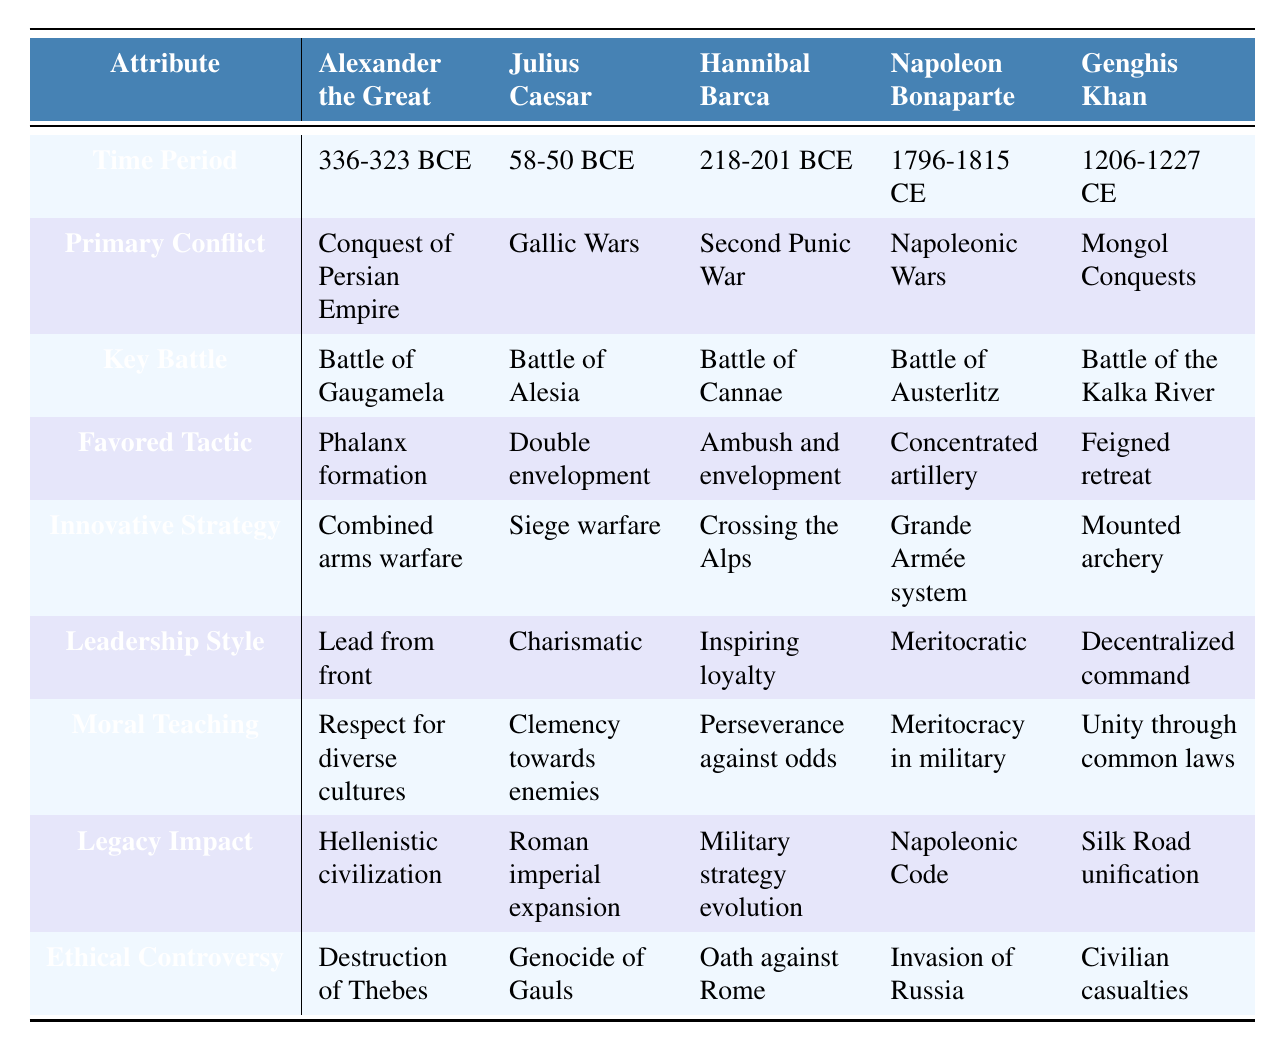What was the primary conflict for Hannibal Barca? The table states the primary conflict for Hannibal Barca is the Second Punic War.
Answer: Second Punic War Which commander had a leadership style characterized as "Meritocratic"? According to the table, Napoleon Bonaparte is identified as having a meritocratic leadership style.
Answer: Napoleon Bonaparte What innovative strategy did Genghis Khan employ? The table indicates that Genghis Khan employed mounted archery as his innovative strategy.
Answer: Mounted archery Which commander is associated with the key battle of Austerlitz? From the table, Napoleon Bonaparte is associated with the key battle of Austerlitz.
Answer: Napoleon Bonaparte Did Julius Caesar have a favored tactic that involved double envelopment? Yes, the table confirms that Julius Caesar favored the tactic of double envelopment.
Answer: Yes Which commander is noted for his moral teaching regarding "Clemency towards enemies"? The table highlights that Julius Caesar is noted for his moral teaching regarding clemency towards enemies.
Answer: Julius Caesar What is the ethical controversy associated with Alexander the Great? The table lists the ethical controversy associated with Alexander the Great as the destruction of Thebes.
Answer: Destruction of Thebes Which commander's era overlaps with the Mongol Conquests? The table states that Genghis Khan's time period directly encompasses the Mongol Conquests.
Answer: Genghis Khan What is the average time period of the commanders listed in the table? The average time period is calculated as (336-323 + 58-50 + 218-201 + 1796-1815 + 1206-1227)/5, simplifying gives approximately 741 CE as an average representation of the time frame.
Answer: Approximately 741 CE Which commander's legacy was to influence the Roman imperial expansion? The table specifies that Julius Caesar's legacy impact was Roman imperial expansion.
Answer: Julius Caesar What favored tactic did Alexander the Great employ, and how does it compare to that of Hannibal Barca? Alexander the Great favored the phalanx formation, whereas Hannibal Barca preferred ambush and envelopment tactics, showcasing different strategies in their respective battles.
Answer: Phalanx formation vs. Ambush and envelopment Which commander had both a strong moral teaching and ethical controversies? The table showcases that Julius Caesar had moral teachings (clemency towards enemies) and ethical controversies (genocide of Gauls).
Answer: Julius Caesar 